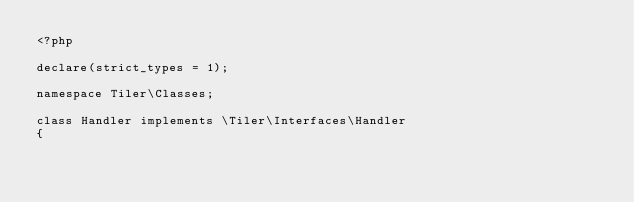Convert code to text. <code><loc_0><loc_0><loc_500><loc_500><_PHP_><?php 

declare(strict_types = 1);

namespace Tiler\Classes;

class Handler implements \Tiler\Interfaces\Handler 
{</code> 